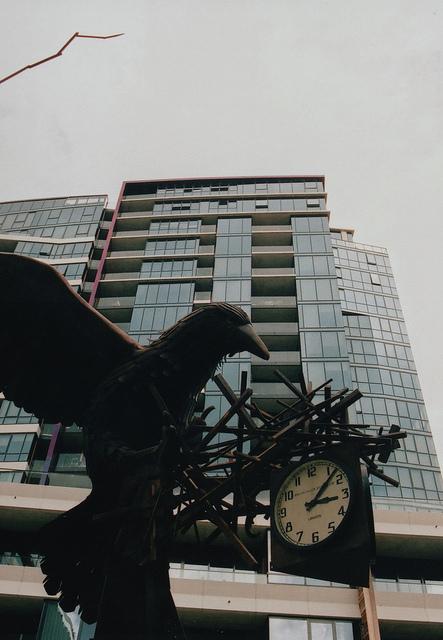What color is the bird?
Answer briefly. Black. Is there a building in this photo?
Concise answer only. Yes. What time is it?
Be succinct. 3:07. 